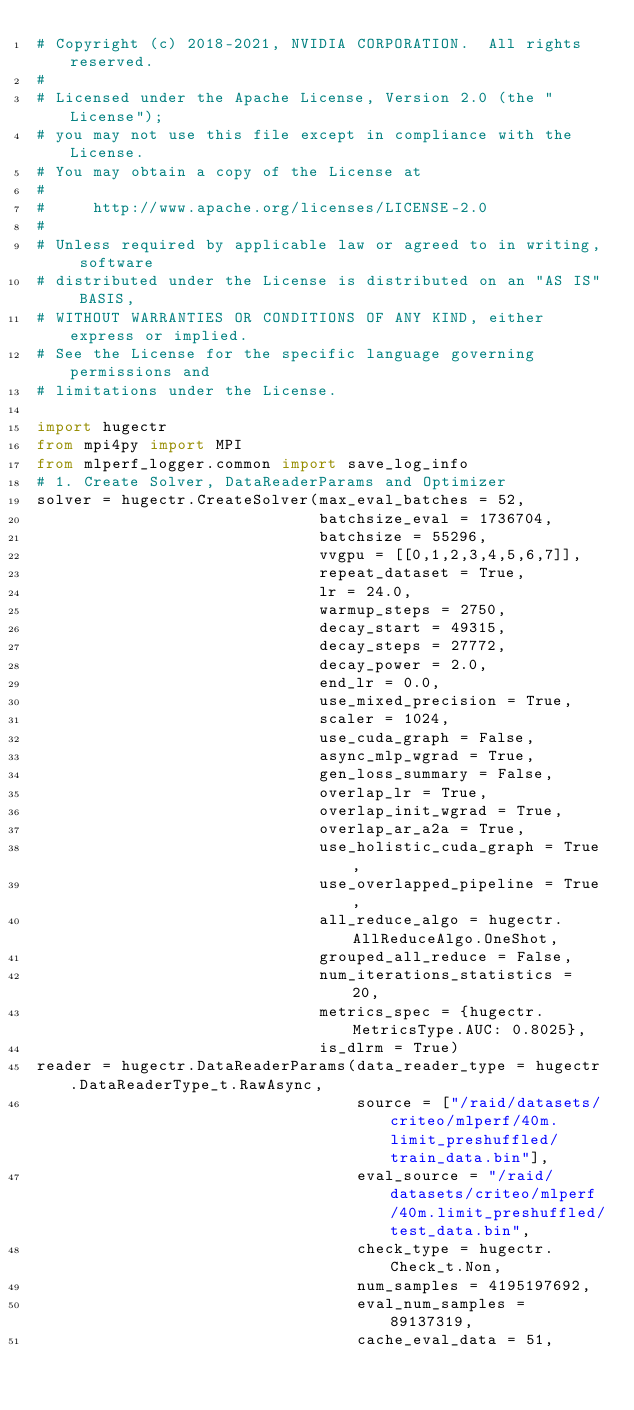<code> <loc_0><loc_0><loc_500><loc_500><_Python_># Copyright (c) 2018-2021, NVIDIA CORPORATION.  All rights reserved.
#
# Licensed under the Apache License, Version 2.0 (the "License");
# you may not use this file except in compliance with the License.
# You may obtain a copy of the License at
#
#     http://www.apache.org/licenses/LICENSE-2.0
#
# Unless required by applicable law or agreed to in writing, software
# distributed under the License is distributed on an "AS IS" BASIS,
# WITHOUT WARRANTIES OR CONDITIONS OF ANY KIND, either express or implied.
# See the License for the specific language governing permissions and
# limitations under the License.

import hugectr
from mpi4py import MPI
from mlperf_logger.common import save_log_info
# 1. Create Solver, DataReaderParams and Optimizer
solver = hugectr.CreateSolver(max_eval_batches = 52,
                              batchsize_eval = 1736704,
                              batchsize = 55296,
                              vvgpu = [[0,1,2,3,4,5,6,7]],
                              repeat_dataset = True,
                              lr = 24.0,
                              warmup_steps = 2750, 
                              decay_start = 49315, 
                              decay_steps = 27772, 
                              decay_power = 2.0,
                              end_lr = 0.0,
                              use_mixed_precision = True,
                              scaler = 1024,
                              use_cuda_graph = False,
                              async_mlp_wgrad = True,
                              gen_loss_summary = False,
                              overlap_lr = True,
                              overlap_init_wgrad = True,
                              overlap_ar_a2a = True,
                              use_holistic_cuda_graph = True,
                              use_overlapped_pipeline = True,
                              all_reduce_algo = hugectr.AllReduceAlgo.OneShot,
                              grouped_all_reduce = False,
                              num_iterations_statistics = 20,
                              metrics_spec = {hugectr.MetricsType.AUC: 0.8025},
                              is_dlrm = True)
reader = hugectr.DataReaderParams(data_reader_type = hugectr.DataReaderType_t.RawAsync,
                                  source = ["/raid/datasets/criteo/mlperf/40m.limit_preshuffled/train_data.bin"],
                                  eval_source = "/raid/datasets/criteo/mlperf/40m.limit_preshuffled/test_data.bin",
                                  check_type = hugectr.Check_t.Non,
                                  num_samples = 4195197692,
                                  eval_num_samples = 89137319,
                                  cache_eval_data = 51,</code> 